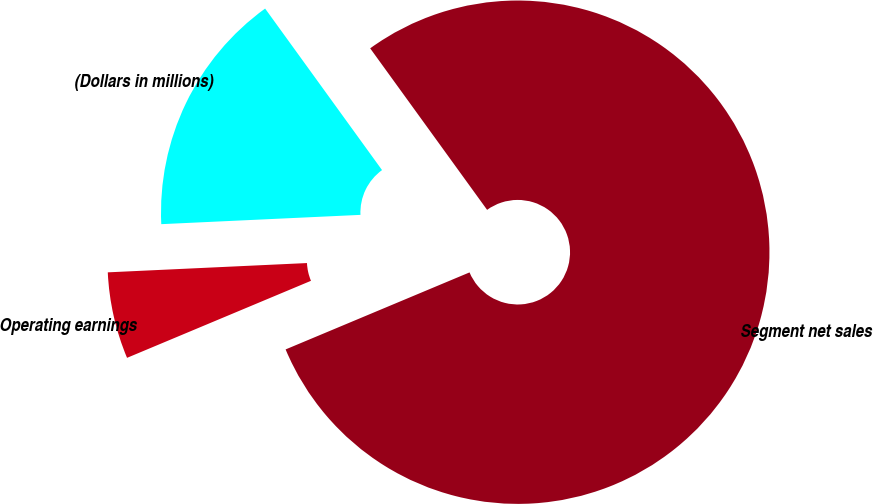Convert chart to OTSL. <chart><loc_0><loc_0><loc_500><loc_500><pie_chart><fcel>(Dollars in millions)<fcel>Segment net sales<fcel>Operating earnings<nl><fcel>15.77%<fcel>78.66%<fcel>5.57%<nl></chart> 